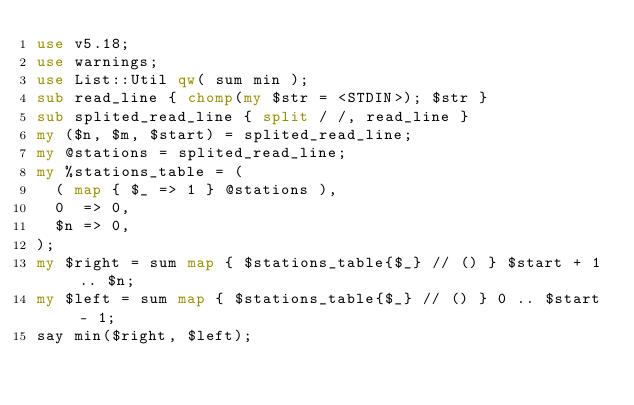<code> <loc_0><loc_0><loc_500><loc_500><_Perl_>use v5.18;
use warnings;
use List::Util qw( sum min );
sub read_line { chomp(my $str = <STDIN>); $str }
sub splited_read_line { split / /, read_line }
my ($n, $m, $start) = splited_read_line;
my @stations = splited_read_line;
my %stations_table = (
  ( map { $_ => 1 } @stations ),
  0  => 0,
  $n => 0,
);
my $right = sum map { $stations_table{$_} // () } $start + 1 .. $n;
my $left = sum map { $stations_table{$_} // () } 0 .. $start - 1;
say min($right, $left);
</code> 